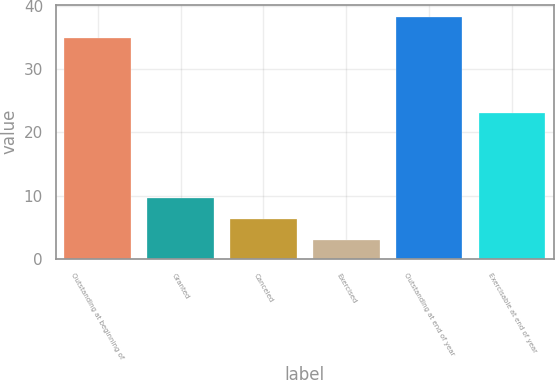<chart> <loc_0><loc_0><loc_500><loc_500><bar_chart><fcel>Outstanding at beginning of<fcel>Granted<fcel>Canceled<fcel>Exercised<fcel>Outstanding at end of year<fcel>Exercisable at end of year<nl><fcel>35<fcel>9.6<fcel>6.3<fcel>3<fcel>38.3<fcel>23<nl></chart> 